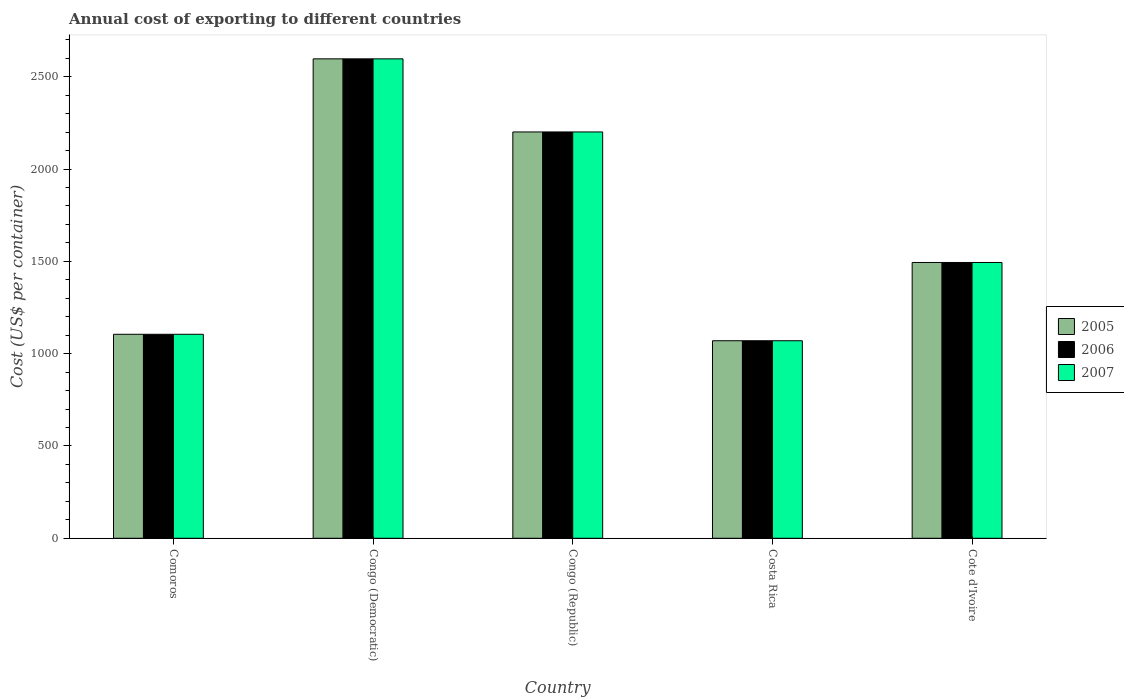How many bars are there on the 5th tick from the right?
Offer a terse response. 3. What is the label of the 4th group of bars from the left?
Your response must be concise. Costa Rica. What is the total annual cost of exporting in 2006 in Comoros?
Keep it short and to the point. 1105. Across all countries, what is the maximum total annual cost of exporting in 2006?
Ensure brevity in your answer.  2597. Across all countries, what is the minimum total annual cost of exporting in 2006?
Provide a succinct answer. 1070. In which country was the total annual cost of exporting in 2005 maximum?
Offer a terse response. Congo (Democratic). What is the total total annual cost of exporting in 2006 in the graph?
Provide a succinct answer. 8467. What is the difference between the total annual cost of exporting in 2005 in Comoros and that in Cote d'Ivoire?
Provide a succinct answer. -389. What is the difference between the total annual cost of exporting in 2006 in Congo (Democratic) and the total annual cost of exporting in 2007 in Cote d'Ivoire?
Make the answer very short. 1103. What is the average total annual cost of exporting in 2007 per country?
Provide a succinct answer. 1693.4. In how many countries, is the total annual cost of exporting in 2007 greater than 2000 US$?
Make the answer very short. 2. What is the ratio of the total annual cost of exporting in 2007 in Congo (Democratic) to that in Congo (Republic)?
Offer a very short reply. 1.18. Is the difference between the total annual cost of exporting in 2006 in Congo (Republic) and Costa Rica greater than the difference between the total annual cost of exporting in 2007 in Congo (Republic) and Costa Rica?
Your answer should be compact. No. What is the difference between the highest and the second highest total annual cost of exporting in 2007?
Make the answer very short. -396. What is the difference between the highest and the lowest total annual cost of exporting in 2007?
Offer a terse response. 1527. In how many countries, is the total annual cost of exporting in 2006 greater than the average total annual cost of exporting in 2006 taken over all countries?
Provide a short and direct response. 2. What does the 3rd bar from the left in Congo (Democratic) represents?
Your answer should be compact. 2007. Are all the bars in the graph horizontal?
Offer a very short reply. No. Does the graph contain any zero values?
Offer a very short reply. No. Where does the legend appear in the graph?
Your answer should be very brief. Center right. How many legend labels are there?
Offer a terse response. 3. How are the legend labels stacked?
Provide a short and direct response. Vertical. What is the title of the graph?
Your answer should be compact. Annual cost of exporting to different countries. Does "1985" appear as one of the legend labels in the graph?
Your answer should be compact. No. What is the label or title of the X-axis?
Give a very brief answer. Country. What is the label or title of the Y-axis?
Ensure brevity in your answer.  Cost (US$ per container). What is the Cost (US$ per container) in 2005 in Comoros?
Make the answer very short. 1105. What is the Cost (US$ per container) of 2006 in Comoros?
Your answer should be very brief. 1105. What is the Cost (US$ per container) in 2007 in Comoros?
Your response must be concise. 1105. What is the Cost (US$ per container) in 2005 in Congo (Democratic)?
Offer a terse response. 2597. What is the Cost (US$ per container) in 2006 in Congo (Democratic)?
Provide a succinct answer. 2597. What is the Cost (US$ per container) of 2007 in Congo (Democratic)?
Give a very brief answer. 2597. What is the Cost (US$ per container) in 2005 in Congo (Republic)?
Your answer should be very brief. 2201. What is the Cost (US$ per container) in 2006 in Congo (Republic)?
Offer a terse response. 2201. What is the Cost (US$ per container) of 2007 in Congo (Republic)?
Offer a very short reply. 2201. What is the Cost (US$ per container) of 2005 in Costa Rica?
Keep it short and to the point. 1070. What is the Cost (US$ per container) of 2006 in Costa Rica?
Give a very brief answer. 1070. What is the Cost (US$ per container) of 2007 in Costa Rica?
Offer a very short reply. 1070. What is the Cost (US$ per container) of 2005 in Cote d'Ivoire?
Your response must be concise. 1494. What is the Cost (US$ per container) in 2006 in Cote d'Ivoire?
Your answer should be compact. 1494. What is the Cost (US$ per container) of 2007 in Cote d'Ivoire?
Provide a succinct answer. 1494. Across all countries, what is the maximum Cost (US$ per container) of 2005?
Make the answer very short. 2597. Across all countries, what is the maximum Cost (US$ per container) of 2006?
Your answer should be very brief. 2597. Across all countries, what is the maximum Cost (US$ per container) of 2007?
Ensure brevity in your answer.  2597. Across all countries, what is the minimum Cost (US$ per container) in 2005?
Offer a very short reply. 1070. Across all countries, what is the minimum Cost (US$ per container) in 2006?
Provide a short and direct response. 1070. Across all countries, what is the minimum Cost (US$ per container) in 2007?
Offer a terse response. 1070. What is the total Cost (US$ per container) in 2005 in the graph?
Provide a short and direct response. 8467. What is the total Cost (US$ per container) in 2006 in the graph?
Provide a short and direct response. 8467. What is the total Cost (US$ per container) of 2007 in the graph?
Offer a terse response. 8467. What is the difference between the Cost (US$ per container) in 2005 in Comoros and that in Congo (Democratic)?
Offer a terse response. -1492. What is the difference between the Cost (US$ per container) in 2006 in Comoros and that in Congo (Democratic)?
Provide a short and direct response. -1492. What is the difference between the Cost (US$ per container) in 2007 in Comoros and that in Congo (Democratic)?
Give a very brief answer. -1492. What is the difference between the Cost (US$ per container) of 2005 in Comoros and that in Congo (Republic)?
Provide a short and direct response. -1096. What is the difference between the Cost (US$ per container) in 2006 in Comoros and that in Congo (Republic)?
Ensure brevity in your answer.  -1096. What is the difference between the Cost (US$ per container) in 2007 in Comoros and that in Congo (Republic)?
Provide a short and direct response. -1096. What is the difference between the Cost (US$ per container) in 2005 in Comoros and that in Costa Rica?
Give a very brief answer. 35. What is the difference between the Cost (US$ per container) of 2006 in Comoros and that in Costa Rica?
Provide a succinct answer. 35. What is the difference between the Cost (US$ per container) of 2007 in Comoros and that in Costa Rica?
Offer a terse response. 35. What is the difference between the Cost (US$ per container) of 2005 in Comoros and that in Cote d'Ivoire?
Provide a short and direct response. -389. What is the difference between the Cost (US$ per container) in 2006 in Comoros and that in Cote d'Ivoire?
Your answer should be very brief. -389. What is the difference between the Cost (US$ per container) in 2007 in Comoros and that in Cote d'Ivoire?
Provide a short and direct response. -389. What is the difference between the Cost (US$ per container) of 2005 in Congo (Democratic) and that in Congo (Republic)?
Offer a terse response. 396. What is the difference between the Cost (US$ per container) of 2006 in Congo (Democratic) and that in Congo (Republic)?
Keep it short and to the point. 396. What is the difference between the Cost (US$ per container) in 2007 in Congo (Democratic) and that in Congo (Republic)?
Ensure brevity in your answer.  396. What is the difference between the Cost (US$ per container) in 2005 in Congo (Democratic) and that in Costa Rica?
Offer a very short reply. 1527. What is the difference between the Cost (US$ per container) in 2006 in Congo (Democratic) and that in Costa Rica?
Keep it short and to the point. 1527. What is the difference between the Cost (US$ per container) in 2007 in Congo (Democratic) and that in Costa Rica?
Make the answer very short. 1527. What is the difference between the Cost (US$ per container) of 2005 in Congo (Democratic) and that in Cote d'Ivoire?
Keep it short and to the point. 1103. What is the difference between the Cost (US$ per container) in 2006 in Congo (Democratic) and that in Cote d'Ivoire?
Your answer should be very brief. 1103. What is the difference between the Cost (US$ per container) of 2007 in Congo (Democratic) and that in Cote d'Ivoire?
Provide a succinct answer. 1103. What is the difference between the Cost (US$ per container) of 2005 in Congo (Republic) and that in Costa Rica?
Your response must be concise. 1131. What is the difference between the Cost (US$ per container) of 2006 in Congo (Republic) and that in Costa Rica?
Provide a succinct answer. 1131. What is the difference between the Cost (US$ per container) in 2007 in Congo (Republic) and that in Costa Rica?
Provide a short and direct response. 1131. What is the difference between the Cost (US$ per container) of 2005 in Congo (Republic) and that in Cote d'Ivoire?
Ensure brevity in your answer.  707. What is the difference between the Cost (US$ per container) of 2006 in Congo (Republic) and that in Cote d'Ivoire?
Give a very brief answer. 707. What is the difference between the Cost (US$ per container) in 2007 in Congo (Republic) and that in Cote d'Ivoire?
Offer a very short reply. 707. What is the difference between the Cost (US$ per container) of 2005 in Costa Rica and that in Cote d'Ivoire?
Ensure brevity in your answer.  -424. What is the difference between the Cost (US$ per container) of 2006 in Costa Rica and that in Cote d'Ivoire?
Give a very brief answer. -424. What is the difference between the Cost (US$ per container) in 2007 in Costa Rica and that in Cote d'Ivoire?
Provide a succinct answer. -424. What is the difference between the Cost (US$ per container) of 2005 in Comoros and the Cost (US$ per container) of 2006 in Congo (Democratic)?
Make the answer very short. -1492. What is the difference between the Cost (US$ per container) in 2005 in Comoros and the Cost (US$ per container) in 2007 in Congo (Democratic)?
Ensure brevity in your answer.  -1492. What is the difference between the Cost (US$ per container) in 2006 in Comoros and the Cost (US$ per container) in 2007 in Congo (Democratic)?
Ensure brevity in your answer.  -1492. What is the difference between the Cost (US$ per container) in 2005 in Comoros and the Cost (US$ per container) in 2006 in Congo (Republic)?
Keep it short and to the point. -1096. What is the difference between the Cost (US$ per container) in 2005 in Comoros and the Cost (US$ per container) in 2007 in Congo (Republic)?
Provide a succinct answer. -1096. What is the difference between the Cost (US$ per container) of 2006 in Comoros and the Cost (US$ per container) of 2007 in Congo (Republic)?
Make the answer very short. -1096. What is the difference between the Cost (US$ per container) in 2006 in Comoros and the Cost (US$ per container) in 2007 in Costa Rica?
Make the answer very short. 35. What is the difference between the Cost (US$ per container) of 2005 in Comoros and the Cost (US$ per container) of 2006 in Cote d'Ivoire?
Ensure brevity in your answer.  -389. What is the difference between the Cost (US$ per container) in 2005 in Comoros and the Cost (US$ per container) in 2007 in Cote d'Ivoire?
Ensure brevity in your answer.  -389. What is the difference between the Cost (US$ per container) in 2006 in Comoros and the Cost (US$ per container) in 2007 in Cote d'Ivoire?
Ensure brevity in your answer.  -389. What is the difference between the Cost (US$ per container) of 2005 in Congo (Democratic) and the Cost (US$ per container) of 2006 in Congo (Republic)?
Offer a very short reply. 396. What is the difference between the Cost (US$ per container) in 2005 in Congo (Democratic) and the Cost (US$ per container) in 2007 in Congo (Republic)?
Ensure brevity in your answer.  396. What is the difference between the Cost (US$ per container) in 2006 in Congo (Democratic) and the Cost (US$ per container) in 2007 in Congo (Republic)?
Give a very brief answer. 396. What is the difference between the Cost (US$ per container) in 2005 in Congo (Democratic) and the Cost (US$ per container) in 2006 in Costa Rica?
Offer a very short reply. 1527. What is the difference between the Cost (US$ per container) in 2005 in Congo (Democratic) and the Cost (US$ per container) in 2007 in Costa Rica?
Your answer should be compact. 1527. What is the difference between the Cost (US$ per container) in 2006 in Congo (Democratic) and the Cost (US$ per container) in 2007 in Costa Rica?
Provide a short and direct response. 1527. What is the difference between the Cost (US$ per container) of 2005 in Congo (Democratic) and the Cost (US$ per container) of 2006 in Cote d'Ivoire?
Offer a terse response. 1103. What is the difference between the Cost (US$ per container) in 2005 in Congo (Democratic) and the Cost (US$ per container) in 2007 in Cote d'Ivoire?
Your answer should be compact. 1103. What is the difference between the Cost (US$ per container) in 2006 in Congo (Democratic) and the Cost (US$ per container) in 2007 in Cote d'Ivoire?
Your answer should be compact. 1103. What is the difference between the Cost (US$ per container) in 2005 in Congo (Republic) and the Cost (US$ per container) in 2006 in Costa Rica?
Provide a short and direct response. 1131. What is the difference between the Cost (US$ per container) in 2005 in Congo (Republic) and the Cost (US$ per container) in 2007 in Costa Rica?
Provide a succinct answer. 1131. What is the difference between the Cost (US$ per container) of 2006 in Congo (Republic) and the Cost (US$ per container) of 2007 in Costa Rica?
Make the answer very short. 1131. What is the difference between the Cost (US$ per container) of 2005 in Congo (Republic) and the Cost (US$ per container) of 2006 in Cote d'Ivoire?
Your response must be concise. 707. What is the difference between the Cost (US$ per container) in 2005 in Congo (Republic) and the Cost (US$ per container) in 2007 in Cote d'Ivoire?
Give a very brief answer. 707. What is the difference between the Cost (US$ per container) of 2006 in Congo (Republic) and the Cost (US$ per container) of 2007 in Cote d'Ivoire?
Your response must be concise. 707. What is the difference between the Cost (US$ per container) in 2005 in Costa Rica and the Cost (US$ per container) in 2006 in Cote d'Ivoire?
Your response must be concise. -424. What is the difference between the Cost (US$ per container) in 2005 in Costa Rica and the Cost (US$ per container) in 2007 in Cote d'Ivoire?
Your answer should be very brief. -424. What is the difference between the Cost (US$ per container) of 2006 in Costa Rica and the Cost (US$ per container) of 2007 in Cote d'Ivoire?
Your answer should be very brief. -424. What is the average Cost (US$ per container) in 2005 per country?
Ensure brevity in your answer.  1693.4. What is the average Cost (US$ per container) of 2006 per country?
Provide a succinct answer. 1693.4. What is the average Cost (US$ per container) of 2007 per country?
Make the answer very short. 1693.4. What is the difference between the Cost (US$ per container) of 2005 and Cost (US$ per container) of 2007 in Comoros?
Your response must be concise. 0. What is the difference between the Cost (US$ per container) in 2006 and Cost (US$ per container) in 2007 in Comoros?
Your answer should be very brief. 0. What is the difference between the Cost (US$ per container) of 2005 and Cost (US$ per container) of 2006 in Congo (Democratic)?
Your answer should be very brief. 0. What is the difference between the Cost (US$ per container) of 2005 and Cost (US$ per container) of 2007 in Congo (Democratic)?
Make the answer very short. 0. What is the difference between the Cost (US$ per container) of 2006 and Cost (US$ per container) of 2007 in Congo (Democratic)?
Your answer should be compact. 0. What is the difference between the Cost (US$ per container) in 2006 and Cost (US$ per container) in 2007 in Congo (Republic)?
Keep it short and to the point. 0. What is the difference between the Cost (US$ per container) of 2005 and Cost (US$ per container) of 2006 in Costa Rica?
Your answer should be very brief. 0. What is the difference between the Cost (US$ per container) in 2005 and Cost (US$ per container) in 2007 in Costa Rica?
Make the answer very short. 0. What is the difference between the Cost (US$ per container) of 2006 and Cost (US$ per container) of 2007 in Costa Rica?
Offer a terse response. 0. What is the ratio of the Cost (US$ per container) of 2005 in Comoros to that in Congo (Democratic)?
Offer a terse response. 0.43. What is the ratio of the Cost (US$ per container) in 2006 in Comoros to that in Congo (Democratic)?
Your answer should be very brief. 0.43. What is the ratio of the Cost (US$ per container) of 2007 in Comoros to that in Congo (Democratic)?
Offer a very short reply. 0.43. What is the ratio of the Cost (US$ per container) in 2005 in Comoros to that in Congo (Republic)?
Make the answer very short. 0.5. What is the ratio of the Cost (US$ per container) in 2006 in Comoros to that in Congo (Republic)?
Provide a succinct answer. 0.5. What is the ratio of the Cost (US$ per container) of 2007 in Comoros to that in Congo (Republic)?
Offer a terse response. 0.5. What is the ratio of the Cost (US$ per container) of 2005 in Comoros to that in Costa Rica?
Make the answer very short. 1.03. What is the ratio of the Cost (US$ per container) in 2006 in Comoros to that in Costa Rica?
Keep it short and to the point. 1.03. What is the ratio of the Cost (US$ per container) of 2007 in Comoros to that in Costa Rica?
Make the answer very short. 1.03. What is the ratio of the Cost (US$ per container) in 2005 in Comoros to that in Cote d'Ivoire?
Your answer should be very brief. 0.74. What is the ratio of the Cost (US$ per container) of 2006 in Comoros to that in Cote d'Ivoire?
Your answer should be very brief. 0.74. What is the ratio of the Cost (US$ per container) of 2007 in Comoros to that in Cote d'Ivoire?
Provide a succinct answer. 0.74. What is the ratio of the Cost (US$ per container) of 2005 in Congo (Democratic) to that in Congo (Republic)?
Ensure brevity in your answer.  1.18. What is the ratio of the Cost (US$ per container) of 2006 in Congo (Democratic) to that in Congo (Republic)?
Provide a short and direct response. 1.18. What is the ratio of the Cost (US$ per container) in 2007 in Congo (Democratic) to that in Congo (Republic)?
Offer a terse response. 1.18. What is the ratio of the Cost (US$ per container) of 2005 in Congo (Democratic) to that in Costa Rica?
Your answer should be very brief. 2.43. What is the ratio of the Cost (US$ per container) in 2006 in Congo (Democratic) to that in Costa Rica?
Offer a terse response. 2.43. What is the ratio of the Cost (US$ per container) of 2007 in Congo (Democratic) to that in Costa Rica?
Offer a very short reply. 2.43. What is the ratio of the Cost (US$ per container) of 2005 in Congo (Democratic) to that in Cote d'Ivoire?
Your response must be concise. 1.74. What is the ratio of the Cost (US$ per container) in 2006 in Congo (Democratic) to that in Cote d'Ivoire?
Provide a succinct answer. 1.74. What is the ratio of the Cost (US$ per container) in 2007 in Congo (Democratic) to that in Cote d'Ivoire?
Provide a succinct answer. 1.74. What is the ratio of the Cost (US$ per container) of 2005 in Congo (Republic) to that in Costa Rica?
Your response must be concise. 2.06. What is the ratio of the Cost (US$ per container) in 2006 in Congo (Republic) to that in Costa Rica?
Offer a terse response. 2.06. What is the ratio of the Cost (US$ per container) of 2007 in Congo (Republic) to that in Costa Rica?
Make the answer very short. 2.06. What is the ratio of the Cost (US$ per container) of 2005 in Congo (Republic) to that in Cote d'Ivoire?
Offer a very short reply. 1.47. What is the ratio of the Cost (US$ per container) of 2006 in Congo (Republic) to that in Cote d'Ivoire?
Give a very brief answer. 1.47. What is the ratio of the Cost (US$ per container) in 2007 in Congo (Republic) to that in Cote d'Ivoire?
Keep it short and to the point. 1.47. What is the ratio of the Cost (US$ per container) of 2005 in Costa Rica to that in Cote d'Ivoire?
Provide a succinct answer. 0.72. What is the ratio of the Cost (US$ per container) of 2006 in Costa Rica to that in Cote d'Ivoire?
Ensure brevity in your answer.  0.72. What is the ratio of the Cost (US$ per container) of 2007 in Costa Rica to that in Cote d'Ivoire?
Your answer should be very brief. 0.72. What is the difference between the highest and the second highest Cost (US$ per container) in 2005?
Your response must be concise. 396. What is the difference between the highest and the second highest Cost (US$ per container) in 2006?
Offer a very short reply. 396. What is the difference between the highest and the second highest Cost (US$ per container) of 2007?
Provide a succinct answer. 396. What is the difference between the highest and the lowest Cost (US$ per container) of 2005?
Your response must be concise. 1527. What is the difference between the highest and the lowest Cost (US$ per container) in 2006?
Keep it short and to the point. 1527. What is the difference between the highest and the lowest Cost (US$ per container) of 2007?
Your response must be concise. 1527. 